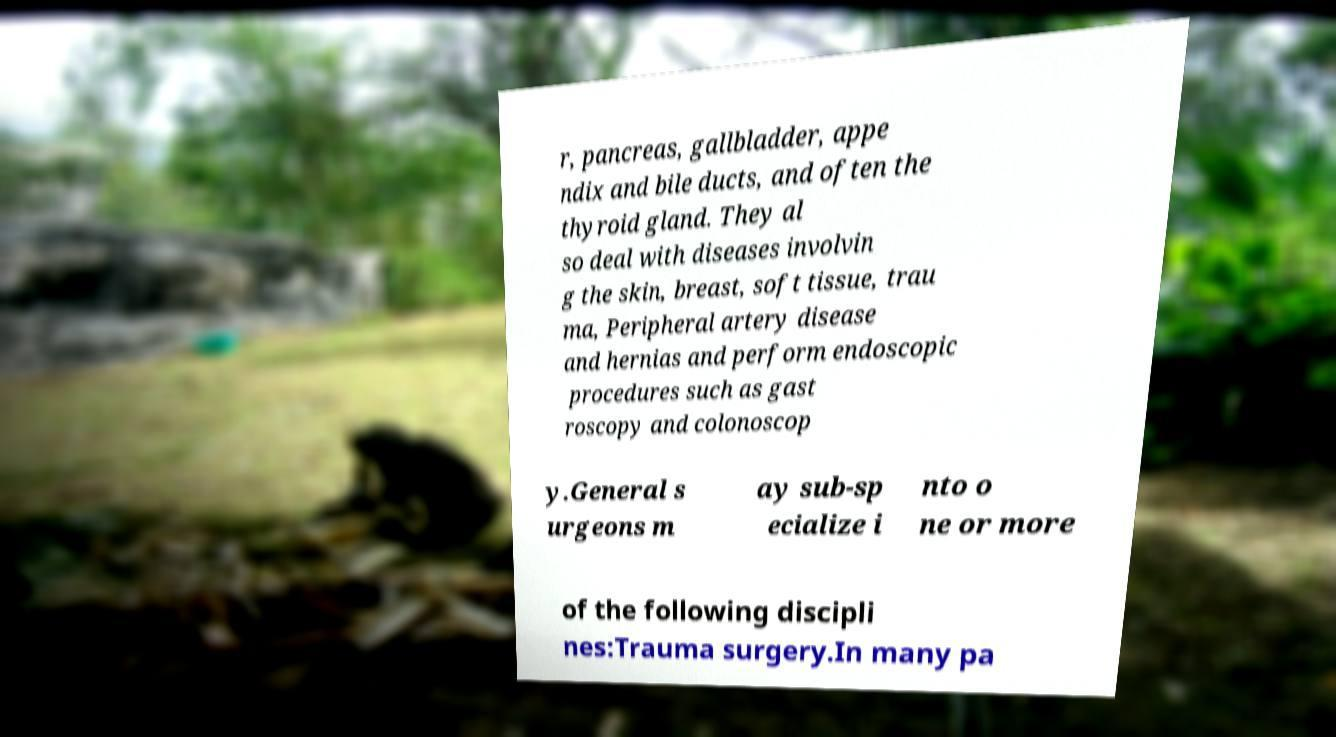I need the written content from this picture converted into text. Can you do that? r, pancreas, gallbladder, appe ndix and bile ducts, and often the thyroid gland. They al so deal with diseases involvin g the skin, breast, soft tissue, trau ma, Peripheral artery disease and hernias and perform endoscopic procedures such as gast roscopy and colonoscop y.General s urgeons m ay sub-sp ecialize i nto o ne or more of the following discipli nes:Trauma surgery.In many pa 